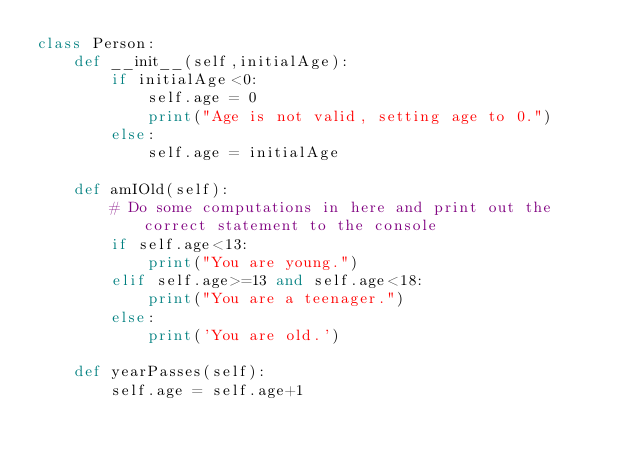<code> <loc_0><loc_0><loc_500><loc_500><_Python_>class Person:
    def __init__(self,initialAge):
        if initialAge<0:
            self.age = 0
            print("Age is not valid, setting age to 0.")
        else:
            self.age = initialAge
    
    def amIOld(self):
        # Do some computations in here and print out the correct statement to the console
        if self.age<13:
            print("You are young.")
        elif self.age>=13 and self.age<18:
            print("You are a teenager.")
        else:
            print('You are old.')
        
    def yearPasses(self):
        self.age = self.age+1
</code> 